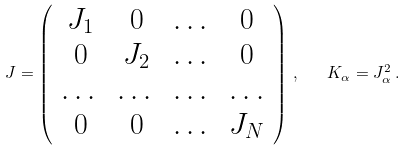Convert formula to latex. <formula><loc_0><loc_0><loc_500><loc_500>J = \left ( \begin{array} { c c c c } J _ { 1 } & 0 & \dots & 0 \\ 0 & J _ { 2 } & \dots & 0 \\ \dots & \dots & \dots & \dots \\ 0 & 0 & \dots & J _ { N } \end{array} \right ) \, , \quad K _ { \alpha } = J _ { \alpha } ^ { 2 } \, .</formula> 